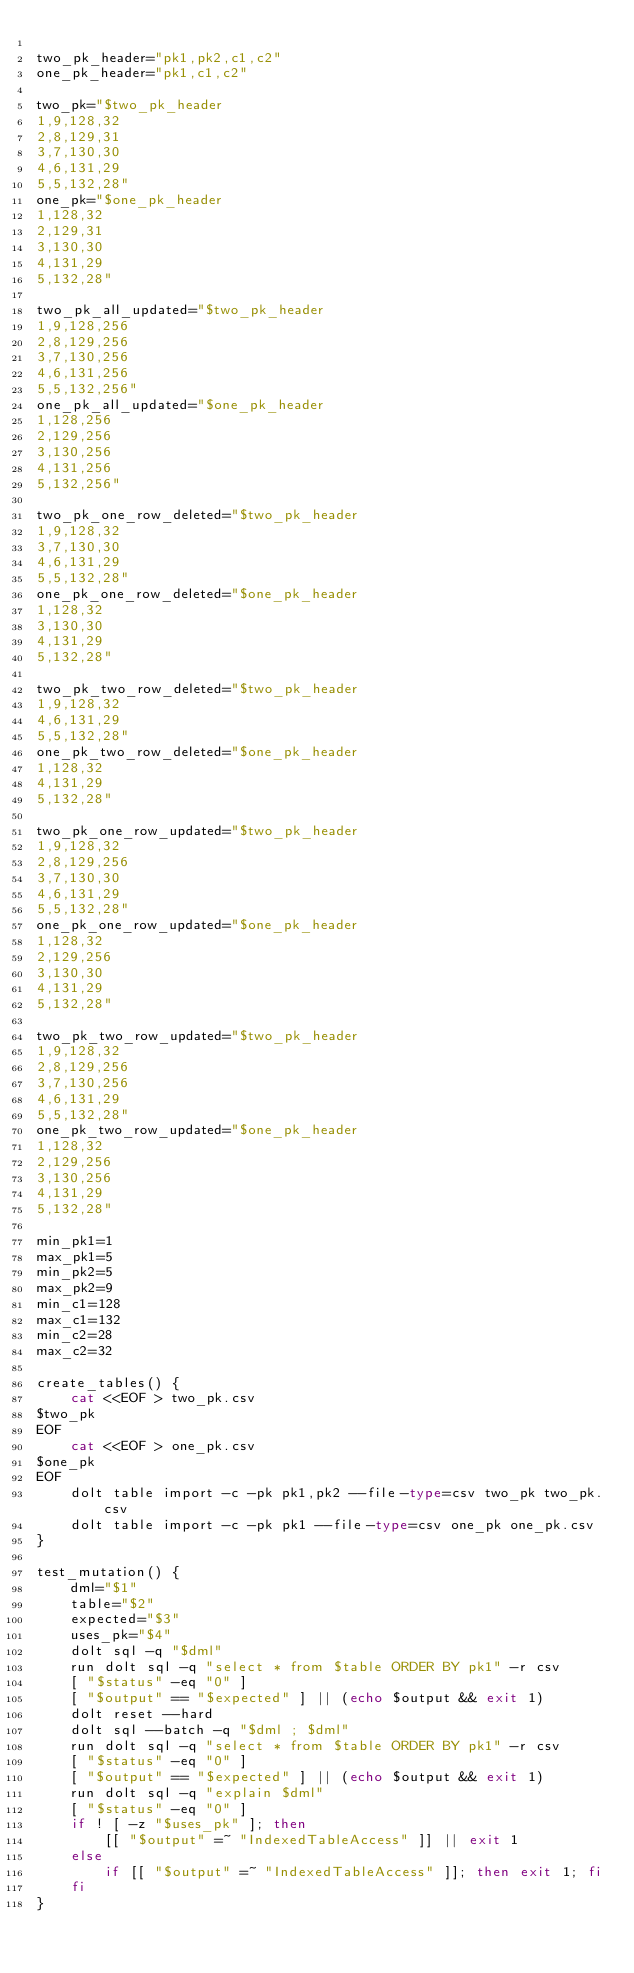Convert code to text. <code><loc_0><loc_0><loc_500><loc_500><_Bash_>
two_pk_header="pk1,pk2,c1,c2"
one_pk_header="pk1,c1,c2"

two_pk="$two_pk_header
1,9,128,32
2,8,129,31
3,7,130,30
4,6,131,29
5,5,132,28"
one_pk="$one_pk_header
1,128,32
2,129,31
3,130,30
4,131,29
5,132,28"

two_pk_all_updated="$two_pk_header
1,9,128,256
2,8,129,256
3,7,130,256
4,6,131,256
5,5,132,256"
one_pk_all_updated="$one_pk_header
1,128,256
2,129,256
3,130,256
4,131,256
5,132,256"

two_pk_one_row_deleted="$two_pk_header
1,9,128,32
3,7,130,30
4,6,131,29
5,5,132,28"
one_pk_one_row_deleted="$one_pk_header
1,128,32
3,130,30
4,131,29
5,132,28"

two_pk_two_row_deleted="$two_pk_header
1,9,128,32
4,6,131,29
5,5,132,28"
one_pk_two_row_deleted="$one_pk_header
1,128,32
4,131,29
5,132,28"

two_pk_one_row_updated="$two_pk_header
1,9,128,32
2,8,129,256
3,7,130,30
4,6,131,29
5,5,132,28"
one_pk_one_row_updated="$one_pk_header
1,128,32
2,129,256
3,130,30
4,131,29
5,132,28"

two_pk_two_row_updated="$two_pk_header
1,9,128,32
2,8,129,256
3,7,130,256
4,6,131,29
5,5,132,28"
one_pk_two_row_updated="$one_pk_header
1,128,32
2,129,256
3,130,256
4,131,29
5,132,28"

min_pk1=1
max_pk1=5
min_pk2=5
max_pk2=9
min_c1=128
max_c1=132
min_c2=28
max_c2=32

create_tables() {
    cat <<EOF > two_pk.csv
$two_pk
EOF
    cat <<EOF > one_pk.csv
$one_pk
EOF
    dolt table import -c -pk pk1,pk2 --file-type=csv two_pk two_pk.csv
    dolt table import -c -pk pk1 --file-type=csv one_pk one_pk.csv
}

test_mutation() {
    dml="$1"
    table="$2"
    expected="$3"
    uses_pk="$4"
    dolt sql -q "$dml"
    run dolt sql -q "select * from $table ORDER BY pk1" -r csv
    [ "$status" -eq "0" ]
    [ "$output" == "$expected" ] || (echo $output && exit 1)
    dolt reset --hard
    dolt sql --batch -q "$dml ; $dml"
    run dolt sql -q "select * from $table ORDER BY pk1" -r csv
    [ "$status" -eq "0" ]
    [ "$output" == "$expected" ] || (echo $output && exit 1)
    run dolt sql -q "explain $dml"
    [ "$status" -eq "0" ]
    if ! [ -z "$uses_pk" ]; then
        [[ "$output" =~ "IndexedTableAccess" ]] || exit 1
    else
        if [[ "$output" =~ "IndexedTableAccess" ]]; then exit 1; fi
    fi
}
</code> 